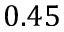<formula> <loc_0><loc_0><loc_500><loc_500>0 . 4 5</formula> 